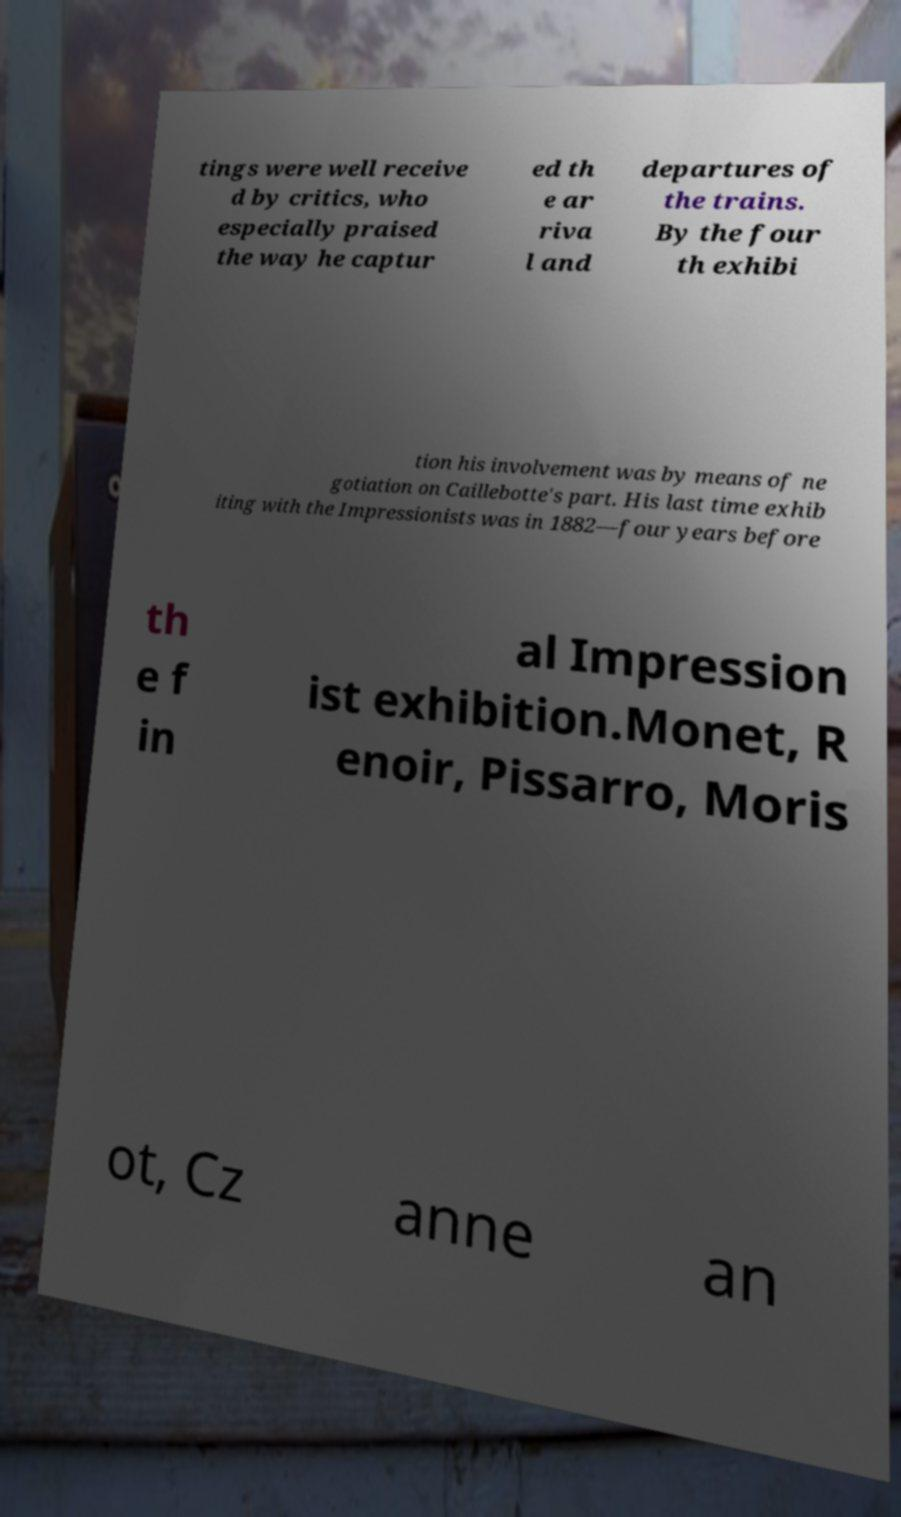What messages or text are displayed in this image? I need them in a readable, typed format. tings were well receive d by critics, who especially praised the way he captur ed th e ar riva l and departures of the trains. By the four th exhibi tion his involvement was by means of ne gotiation on Caillebotte's part. His last time exhib iting with the Impressionists was in 1882—four years before th e f in al Impression ist exhibition.Monet, R enoir, Pissarro, Moris ot, Cz anne an 